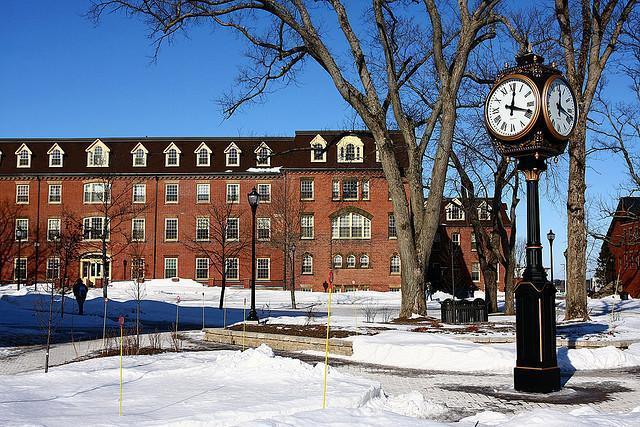What is the coldest place in the area?
Answer the question by selecting the correct answer among the 4 following choices and explain your choice with a short sentence. The answer should be formatted with the following format: `Answer: choice
Rationale: rationale.`
Options: By clock, by building, by tree, shaded area. Answer: shaded area.
Rationale: The coldest place is the shaded area without sunlight. 